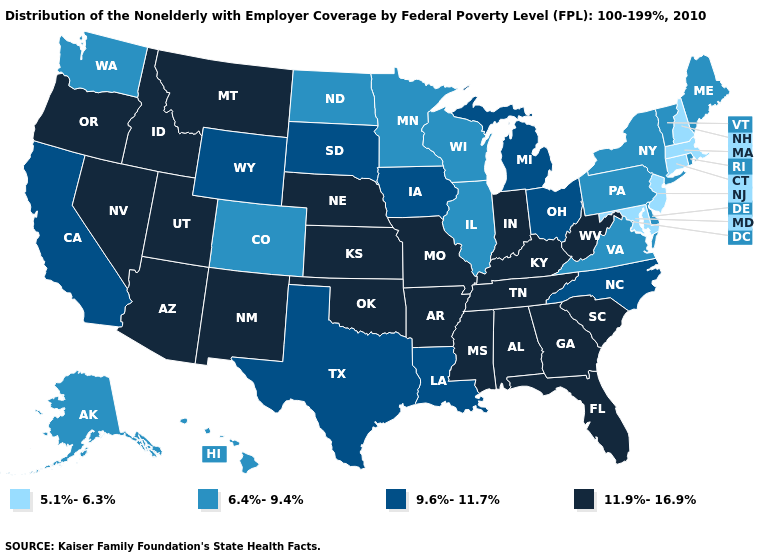Does New Jersey have the lowest value in the USA?
Keep it brief. Yes. What is the value of Kentucky?
Short answer required. 11.9%-16.9%. Does North Carolina have the same value as South Dakota?
Quick response, please. Yes. What is the value of Washington?
Short answer required. 6.4%-9.4%. Does Mississippi have a lower value than New Hampshire?
Write a very short answer. No. Does Michigan have the same value as Minnesota?
Keep it brief. No. What is the value of Michigan?
Write a very short answer. 9.6%-11.7%. Does the first symbol in the legend represent the smallest category?
Answer briefly. Yes. Name the states that have a value in the range 6.4%-9.4%?
Answer briefly. Alaska, Colorado, Delaware, Hawaii, Illinois, Maine, Minnesota, New York, North Dakota, Pennsylvania, Rhode Island, Vermont, Virginia, Washington, Wisconsin. Is the legend a continuous bar?
Short answer required. No. Name the states that have a value in the range 6.4%-9.4%?
Give a very brief answer. Alaska, Colorado, Delaware, Hawaii, Illinois, Maine, Minnesota, New York, North Dakota, Pennsylvania, Rhode Island, Vermont, Virginia, Washington, Wisconsin. What is the value of North Carolina?
Give a very brief answer. 9.6%-11.7%. What is the lowest value in the MidWest?
Be succinct. 6.4%-9.4%. What is the highest value in the Northeast ?
Give a very brief answer. 6.4%-9.4%. 